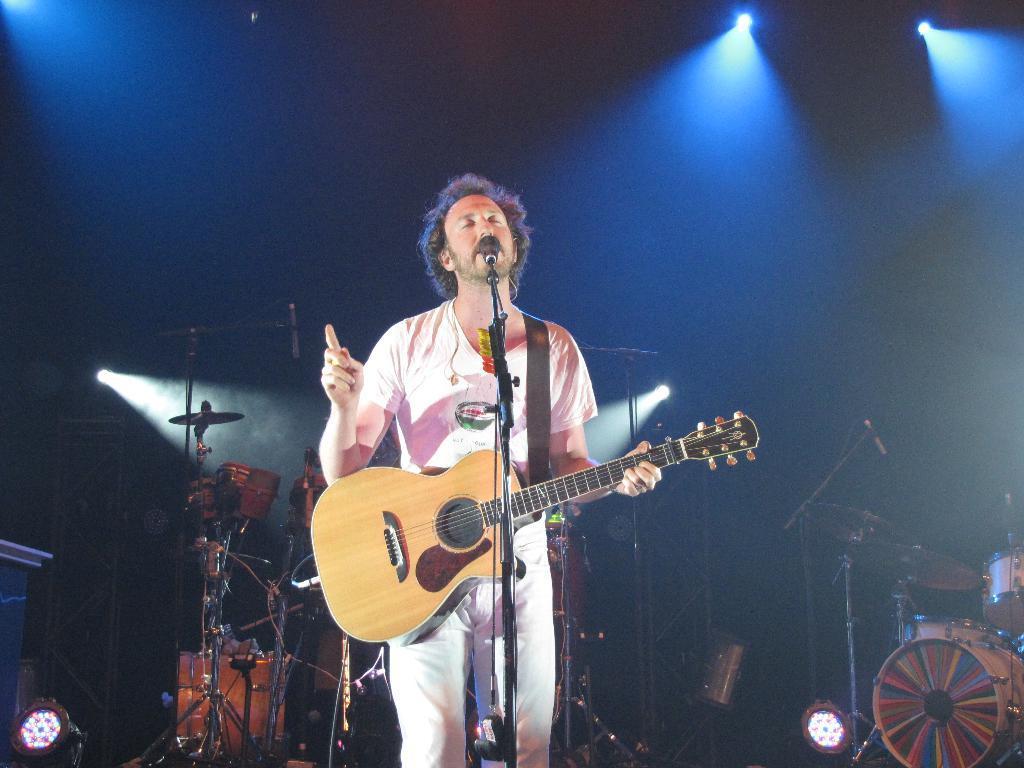Could you give a brief overview of what you see in this image? In the center there is a man standing and holding guitar. In front we can see microphone. In the background there is a wall,light and few musical instruments. 